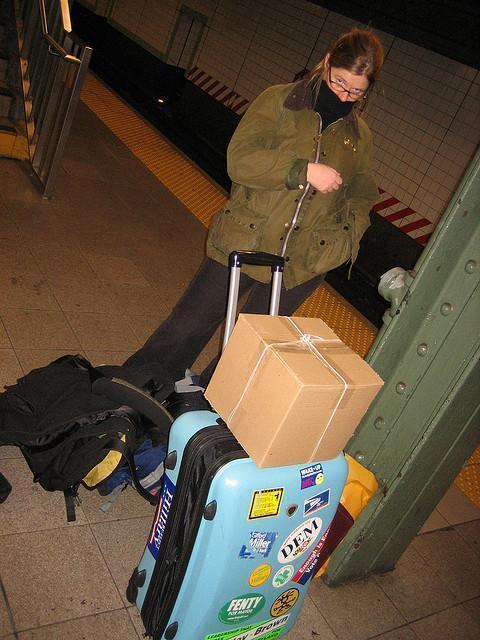What type of area is the woman waiting in?
Answer the question by selecting the correct answer among the 4 following choices.
Options: Lobby, hotel, subway, bus stop. Subway. 